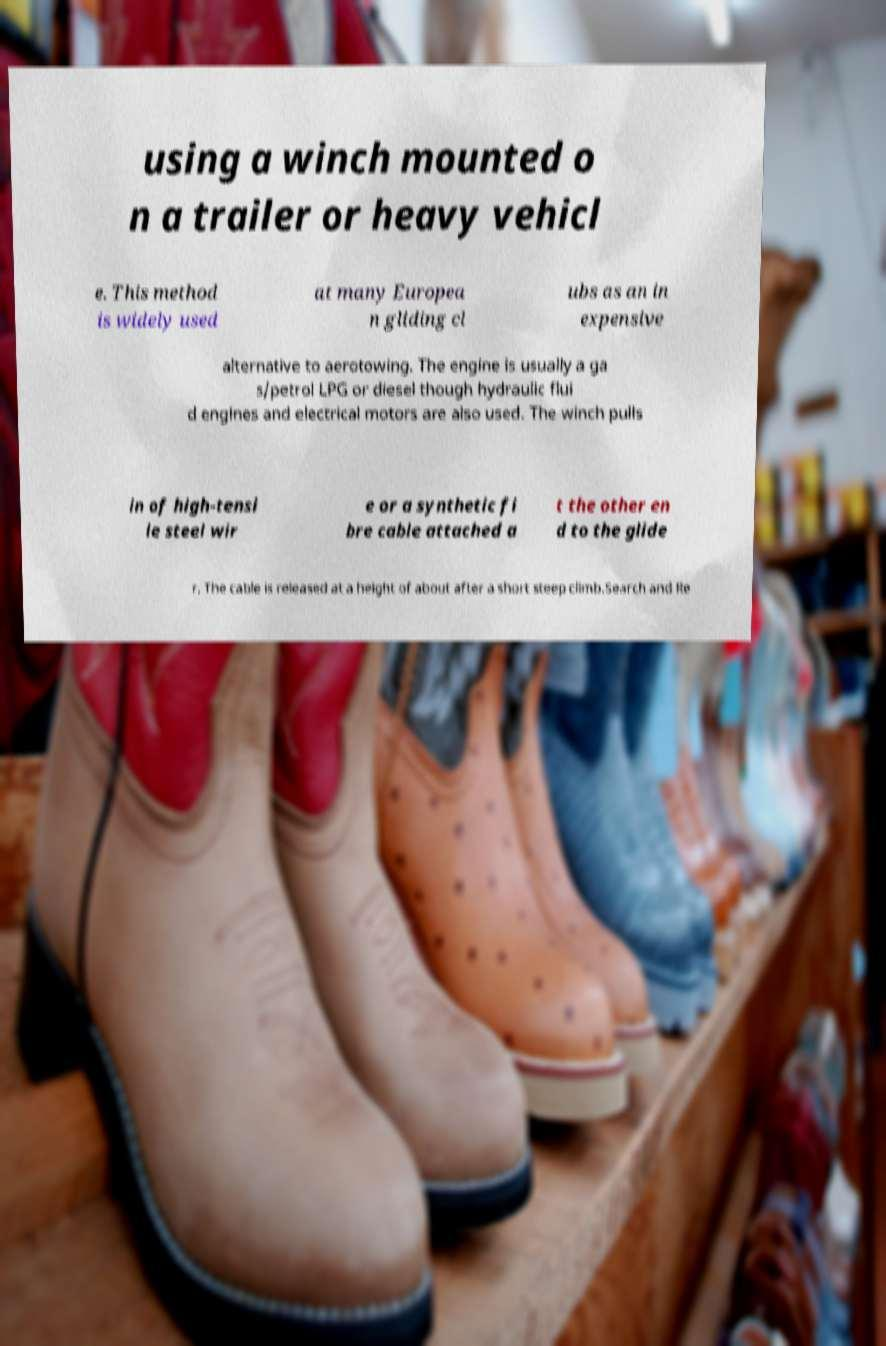I need the written content from this picture converted into text. Can you do that? using a winch mounted o n a trailer or heavy vehicl e. This method is widely used at many Europea n gliding cl ubs as an in expensive alternative to aerotowing. The engine is usually a ga s/petrol LPG or diesel though hydraulic flui d engines and electrical motors are also used. The winch pulls in of high-tensi le steel wir e or a synthetic fi bre cable attached a t the other en d to the glide r. The cable is released at a height of about after a short steep climb.Search and Re 